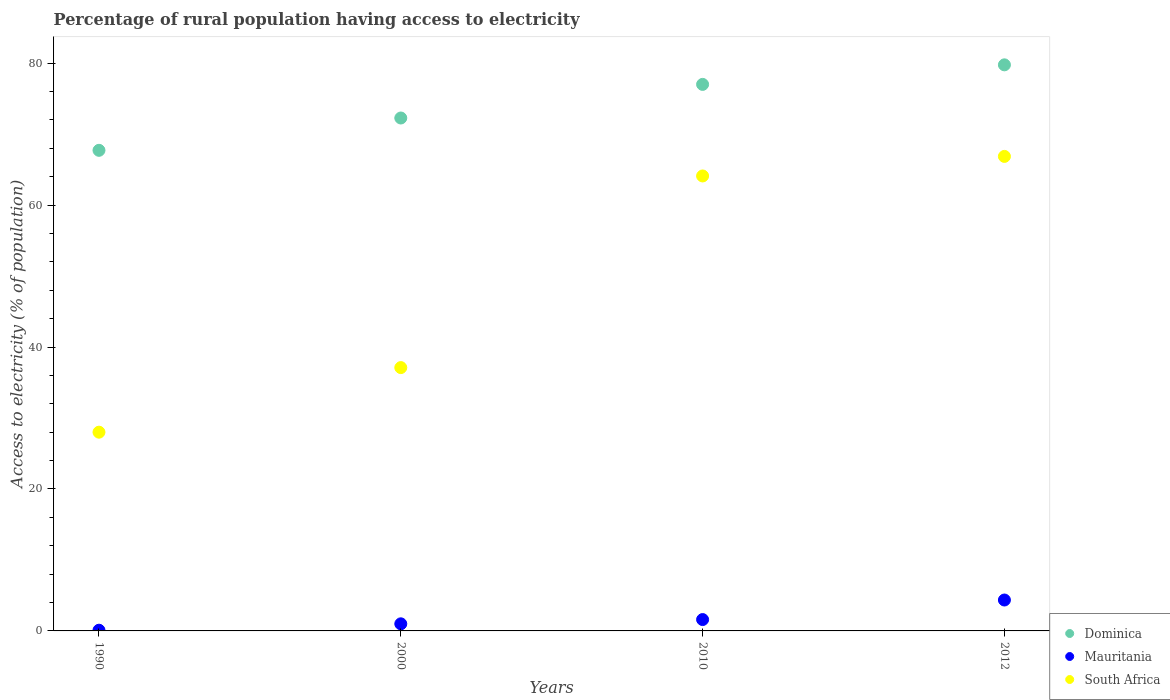How many different coloured dotlines are there?
Offer a very short reply. 3. Is the number of dotlines equal to the number of legend labels?
Offer a terse response. Yes. What is the percentage of rural population having access to electricity in Mauritania in 2010?
Ensure brevity in your answer.  1.6. Across all years, what is the maximum percentage of rural population having access to electricity in Dominica?
Your answer should be compact. 79.75. Across all years, what is the minimum percentage of rural population having access to electricity in Dominica?
Offer a terse response. 67.71. What is the total percentage of rural population having access to electricity in Dominica in the graph?
Your answer should be compact. 296.73. What is the difference between the percentage of rural population having access to electricity in Mauritania in 1990 and that in 2012?
Provide a short and direct response. -4.25. What is the difference between the percentage of rural population having access to electricity in Mauritania in 1990 and the percentage of rural population having access to electricity in Dominica in 2010?
Offer a terse response. -76.9. What is the average percentage of rural population having access to electricity in Mauritania per year?
Your response must be concise. 1.76. In the year 2010, what is the difference between the percentage of rural population having access to electricity in Dominica and percentage of rural population having access to electricity in South Africa?
Your answer should be compact. 12.9. What is the ratio of the percentage of rural population having access to electricity in South Africa in 2000 to that in 2010?
Provide a short and direct response. 0.58. What is the difference between the highest and the second highest percentage of rural population having access to electricity in Mauritania?
Provide a succinct answer. 2.75. What is the difference between the highest and the lowest percentage of rural population having access to electricity in South Africa?
Offer a very short reply. 38.85. In how many years, is the percentage of rural population having access to electricity in South Africa greater than the average percentage of rural population having access to electricity in South Africa taken over all years?
Offer a terse response. 2. Is it the case that in every year, the sum of the percentage of rural population having access to electricity in South Africa and percentage of rural population having access to electricity in Mauritania  is greater than the percentage of rural population having access to electricity in Dominica?
Keep it short and to the point. No. Does the percentage of rural population having access to electricity in Dominica monotonically increase over the years?
Keep it short and to the point. Yes. Is the percentage of rural population having access to electricity in South Africa strictly greater than the percentage of rural population having access to electricity in Dominica over the years?
Provide a short and direct response. No. Is the percentage of rural population having access to electricity in Dominica strictly less than the percentage of rural population having access to electricity in South Africa over the years?
Your answer should be compact. No. How many dotlines are there?
Ensure brevity in your answer.  3. How many years are there in the graph?
Provide a succinct answer. 4. Are the values on the major ticks of Y-axis written in scientific E-notation?
Give a very brief answer. No. Does the graph contain grids?
Ensure brevity in your answer.  No. Where does the legend appear in the graph?
Keep it short and to the point. Bottom right. What is the title of the graph?
Ensure brevity in your answer.  Percentage of rural population having access to electricity. Does "Low income" appear as one of the legend labels in the graph?
Your answer should be very brief. No. What is the label or title of the X-axis?
Offer a terse response. Years. What is the label or title of the Y-axis?
Give a very brief answer. Access to electricity (% of population). What is the Access to electricity (% of population) in Dominica in 1990?
Offer a very short reply. 67.71. What is the Access to electricity (% of population) of Dominica in 2000?
Make the answer very short. 72.27. What is the Access to electricity (% of population) of South Africa in 2000?
Ensure brevity in your answer.  37.1. What is the Access to electricity (% of population) in Mauritania in 2010?
Give a very brief answer. 1.6. What is the Access to electricity (% of population) in South Africa in 2010?
Offer a very short reply. 64.1. What is the Access to electricity (% of population) in Dominica in 2012?
Make the answer very short. 79.75. What is the Access to electricity (% of population) of Mauritania in 2012?
Offer a very short reply. 4.35. What is the Access to electricity (% of population) of South Africa in 2012?
Provide a short and direct response. 66.85. Across all years, what is the maximum Access to electricity (% of population) in Dominica?
Your answer should be compact. 79.75. Across all years, what is the maximum Access to electricity (% of population) of Mauritania?
Offer a very short reply. 4.35. Across all years, what is the maximum Access to electricity (% of population) in South Africa?
Offer a very short reply. 66.85. Across all years, what is the minimum Access to electricity (% of population) of Dominica?
Your answer should be compact. 67.71. Across all years, what is the minimum Access to electricity (% of population) of Mauritania?
Provide a succinct answer. 0.1. What is the total Access to electricity (% of population) in Dominica in the graph?
Your answer should be compact. 296.73. What is the total Access to electricity (% of population) of Mauritania in the graph?
Make the answer very short. 7.05. What is the total Access to electricity (% of population) of South Africa in the graph?
Your answer should be compact. 196.05. What is the difference between the Access to electricity (% of population) in Dominica in 1990 and that in 2000?
Offer a very short reply. -4.55. What is the difference between the Access to electricity (% of population) in South Africa in 1990 and that in 2000?
Your answer should be compact. -9.1. What is the difference between the Access to electricity (% of population) of Dominica in 1990 and that in 2010?
Ensure brevity in your answer.  -9.29. What is the difference between the Access to electricity (% of population) of Mauritania in 1990 and that in 2010?
Ensure brevity in your answer.  -1.5. What is the difference between the Access to electricity (% of population) of South Africa in 1990 and that in 2010?
Provide a short and direct response. -36.1. What is the difference between the Access to electricity (% of population) in Dominica in 1990 and that in 2012?
Make the answer very short. -12.04. What is the difference between the Access to electricity (% of population) of Mauritania in 1990 and that in 2012?
Offer a terse response. -4.25. What is the difference between the Access to electricity (% of population) of South Africa in 1990 and that in 2012?
Provide a short and direct response. -38.85. What is the difference between the Access to electricity (% of population) of Dominica in 2000 and that in 2010?
Offer a terse response. -4.74. What is the difference between the Access to electricity (% of population) in Dominica in 2000 and that in 2012?
Your response must be concise. -7.49. What is the difference between the Access to electricity (% of population) of Mauritania in 2000 and that in 2012?
Your answer should be very brief. -3.35. What is the difference between the Access to electricity (% of population) of South Africa in 2000 and that in 2012?
Keep it short and to the point. -29.75. What is the difference between the Access to electricity (% of population) in Dominica in 2010 and that in 2012?
Provide a short and direct response. -2.75. What is the difference between the Access to electricity (% of population) of Mauritania in 2010 and that in 2012?
Your answer should be compact. -2.75. What is the difference between the Access to electricity (% of population) of South Africa in 2010 and that in 2012?
Ensure brevity in your answer.  -2.75. What is the difference between the Access to electricity (% of population) of Dominica in 1990 and the Access to electricity (% of population) of Mauritania in 2000?
Your response must be concise. 66.71. What is the difference between the Access to electricity (% of population) of Dominica in 1990 and the Access to electricity (% of population) of South Africa in 2000?
Your answer should be compact. 30.61. What is the difference between the Access to electricity (% of population) of Mauritania in 1990 and the Access to electricity (% of population) of South Africa in 2000?
Offer a terse response. -37. What is the difference between the Access to electricity (% of population) of Dominica in 1990 and the Access to electricity (% of population) of Mauritania in 2010?
Provide a succinct answer. 66.11. What is the difference between the Access to electricity (% of population) of Dominica in 1990 and the Access to electricity (% of population) of South Africa in 2010?
Your response must be concise. 3.61. What is the difference between the Access to electricity (% of population) in Mauritania in 1990 and the Access to electricity (% of population) in South Africa in 2010?
Make the answer very short. -64. What is the difference between the Access to electricity (% of population) in Dominica in 1990 and the Access to electricity (% of population) in Mauritania in 2012?
Give a very brief answer. 63.36. What is the difference between the Access to electricity (% of population) in Dominica in 1990 and the Access to electricity (% of population) in South Africa in 2012?
Give a very brief answer. 0.86. What is the difference between the Access to electricity (% of population) of Mauritania in 1990 and the Access to electricity (% of population) of South Africa in 2012?
Your response must be concise. -66.75. What is the difference between the Access to electricity (% of population) of Dominica in 2000 and the Access to electricity (% of population) of Mauritania in 2010?
Your answer should be very brief. 70.67. What is the difference between the Access to electricity (% of population) of Dominica in 2000 and the Access to electricity (% of population) of South Africa in 2010?
Offer a terse response. 8.16. What is the difference between the Access to electricity (% of population) of Mauritania in 2000 and the Access to electricity (% of population) of South Africa in 2010?
Ensure brevity in your answer.  -63.1. What is the difference between the Access to electricity (% of population) in Dominica in 2000 and the Access to electricity (% of population) in Mauritania in 2012?
Keep it short and to the point. 67.91. What is the difference between the Access to electricity (% of population) in Dominica in 2000 and the Access to electricity (% of population) in South Africa in 2012?
Offer a terse response. 5.41. What is the difference between the Access to electricity (% of population) of Mauritania in 2000 and the Access to electricity (% of population) of South Africa in 2012?
Ensure brevity in your answer.  -65.85. What is the difference between the Access to electricity (% of population) of Dominica in 2010 and the Access to electricity (% of population) of Mauritania in 2012?
Provide a short and direct response. 72.65. What is the difference between the Access to electricity (% of population) of Dominica in 2010 and the Access to electricity (% of population) of South Africa in 2012?
Your answer should be compact. 10.15. What is the difference between the Access to electricity (% of population) of Mauritania in 2010 and the Access to electricity (% of population) of South Africa in 2012?
Ensure brevity in your answer.  -65.25. What is the average Access to electricity (% of population) in Dominica per year?
Make the answer very short. 74.18. What is the average Access to electricity (% of population) in Mauritania per year?
Your answer should be compact. 1.76. What is the average Access to electricity (% of population) in South Africa per year?
Keep it short and to the point. 49.01. In the year 1990, what is the difference between the Access to electricity (% of population) of Dominica and Access to electricity (% of population) of Mauritania?
Provide a short and direct response. 67.61. In the year 1990, what is the difference between the Access to electricity (% of population) of Dominica and Access to electricity (% of population) of South Africa?
Your answer should be very brief. 39.71. In the year 1990, what is the difference between the Access to electricity (% of population) of Mauritania and Access to electricity (% of population) of South Africa?
Keep it short and to the point. -27.9. In the year 2000, what is the difference between the Access to electricity (% of population) of Dominica and Access to electricity (% of population) of Mauritania?
Your response must be concise. 71.27. In the year 2000, what is the difference between the Access to electricity (% of population) of Dominica and Access to electricity (% of population) of South Africa?
Keep it short and to the point. 35.16. In the year 2000, what is the difference between the Access to electricity (% of population) of Mauritania and Access to electricity (% of population) of South Africa?
Offer a very short reply. -36.1. In the year 2010, what is the difference between the Access to electricity (% of population) in Dominica and Access to electricity (% of population) in Mauritania?
Offer a very short reply. 75.4. In the year 2010, what is the difference between the Access to electricity (% of population) in Dominica and Access to electricity (% of population) in South Africa?
Keep it short and to the point. 12.9. In the year 2010, what is the difference between the Access to electricity (% of population) in Mauritania and Access to electricity (% of population) in South Africa?
Your response must be concise. -62.5. In the year 2012, what is the difference between the Access to electricity (% of population) in Dominica and Access to electricity (% of population) in Mauritania?
Make the answer very short. 75.4. In the year 2012, what is the difference between the Access to electricity (% of population) in Mauritania and Access to electricity (% of population) in South Africa?
Your answer should be compact. -62.5. What is the ratio of the Access to electricity (% of population) in Dominica in 1990 to that in 2000?
Give a very brief answer. 0.94. What is the ratio of the Access to electricity (% of population) of Mauritania in 1990 to that in 2000?
Give a very brief answer. 0.1. What is the ratio of the Access to electricity (% of population) in South Africa in 1990 to that in 2000?
Provide a succinct answer. 0.75. What is the ratio of the Access to electricity (% of population) of Dominica in 1990 to that in 2010?
Keep it short and to the point. 0.88. What is the ratio of the Access to electricity (% of population) of Mauritania in 1990 to that in 2010?
Ensure brevity in your answer.  0.06. What is the ratio of the Access to electricity (% of population) of South Africa in 1990 to that in 2010?
Your answer should be compact. 0.44. What is the ratio of the Access to electricity (% of population) in Dominica in 1990 to that in 2012?
Your answer should be compact. 0.85. What is the ratio of the Access to electricity (% of population) of Mauritania in 1990 to that in 2012?
Provide a short and direct response. 0.02. What is the ratio of the Access to electricity (% of population) in South Africa in 1990 to that in 2012?
Make the answer very short. 0.42. What is the ratio of the Access to electricity (% of population) of Dominica in 2000 to that in 2010?
Make the answer very short. 0.94. What is the ratio of the Access to electricity (% of population) of Mauritania in 2000 to that in 2010?
Your answer should be very brief. 0.62. What is the ratio of the Access to electricity (% of population) in South Africa in 2000 to that in 2010?
Keep it short and to the point. 0.58. What is the ratio of the Access to electricity (% of population) in Dominica in 2000 to that in 2012?
Make the answer very short. 0.91. What is the ratio of the Access to electricity (% of population) of Mauritania in 2000 to that in 2012?
Your response must be concise. 0.23. What is the ratio of the Access to electricity (% of population) in South Africa in 2000 to that in 2012?
Give a very brief answer. 0.55. What is the ratio of the Access to electricity (% of population) in Dominica in 2010 to that in 2012?
Offer a terse response. 0.97. What is the ratio of the Access to electricity (% of population) of Mauritania in 2010 to that in 2012?
Make the answer very short. 0.37. What is the ratio of the Access to electricity (% of population) in South Africa in 2010 to that in 2012?
Provide a succinct answer. 0.96. What is the difference between the highest and the second highest Access to electricity (% of population) of Dominica?
Provide a short and direct response. 2.75. What is the difference between the highest and the second highest Access to electricity (% of population) of Mauritania?
Ensure brevity in your answer.  2.75. What is the difference between the highest and the second highest Access to electricity (% of population) in South Africa?
Make the answer very short. 2.75. What is the difference between the highest and the lowest Access to electricity (% of population) of Dominica?
Make the answer very short. 12.04. What is the difference between the highest and the lowest Access to electricity (% of population) of Mauritania?
Offer a very short reply. 4.25. What is the difference between the highest and the lowest Access to electricity (% of population) in South Africa?
Your answer should be very brief. 38.85. 